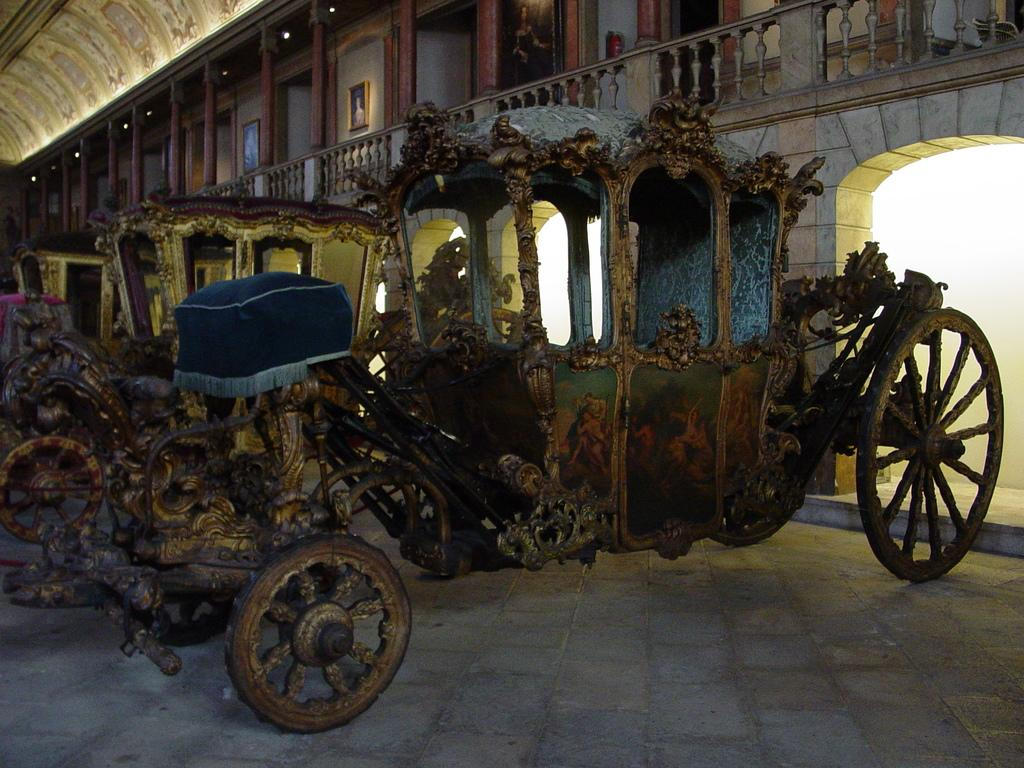Where was the image taken? The image was taken inside a hall. What can be seen in the center of the image? There are carts in the center of the image. What architectural feature is visible on the right side of the image? There are pillars on the right side of the image. What is visible at the top of the image? There are lights at the top of the image. How many friends is the baby playing with in the image? There is no baby or friends present in the image. What is the baby doing in the image? There is no baby in the image, so it cannot be determined what the baby might be doing. 